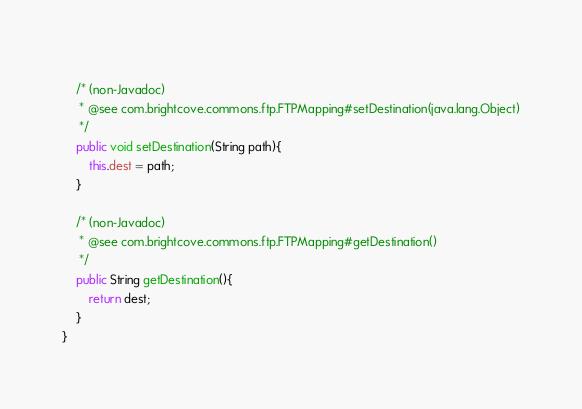<code> <loc_0><loc_0><loc_500><loc_500><_Java_>	
	/* (non-Javadoc)
	 * @see com.brightcove.commons.ftp.FTPMapping#setDestination(java.lang.Object)
	 */
	public void setDestination(String path){
		this.dest = path;
	}
	
	/* (non-Javadoc)
	 * @see com.brightcove.commons.ftp.FTPMapping#getDestination()
	 */
	public String getDestination(){
		return dest;
	}
}
</code> 